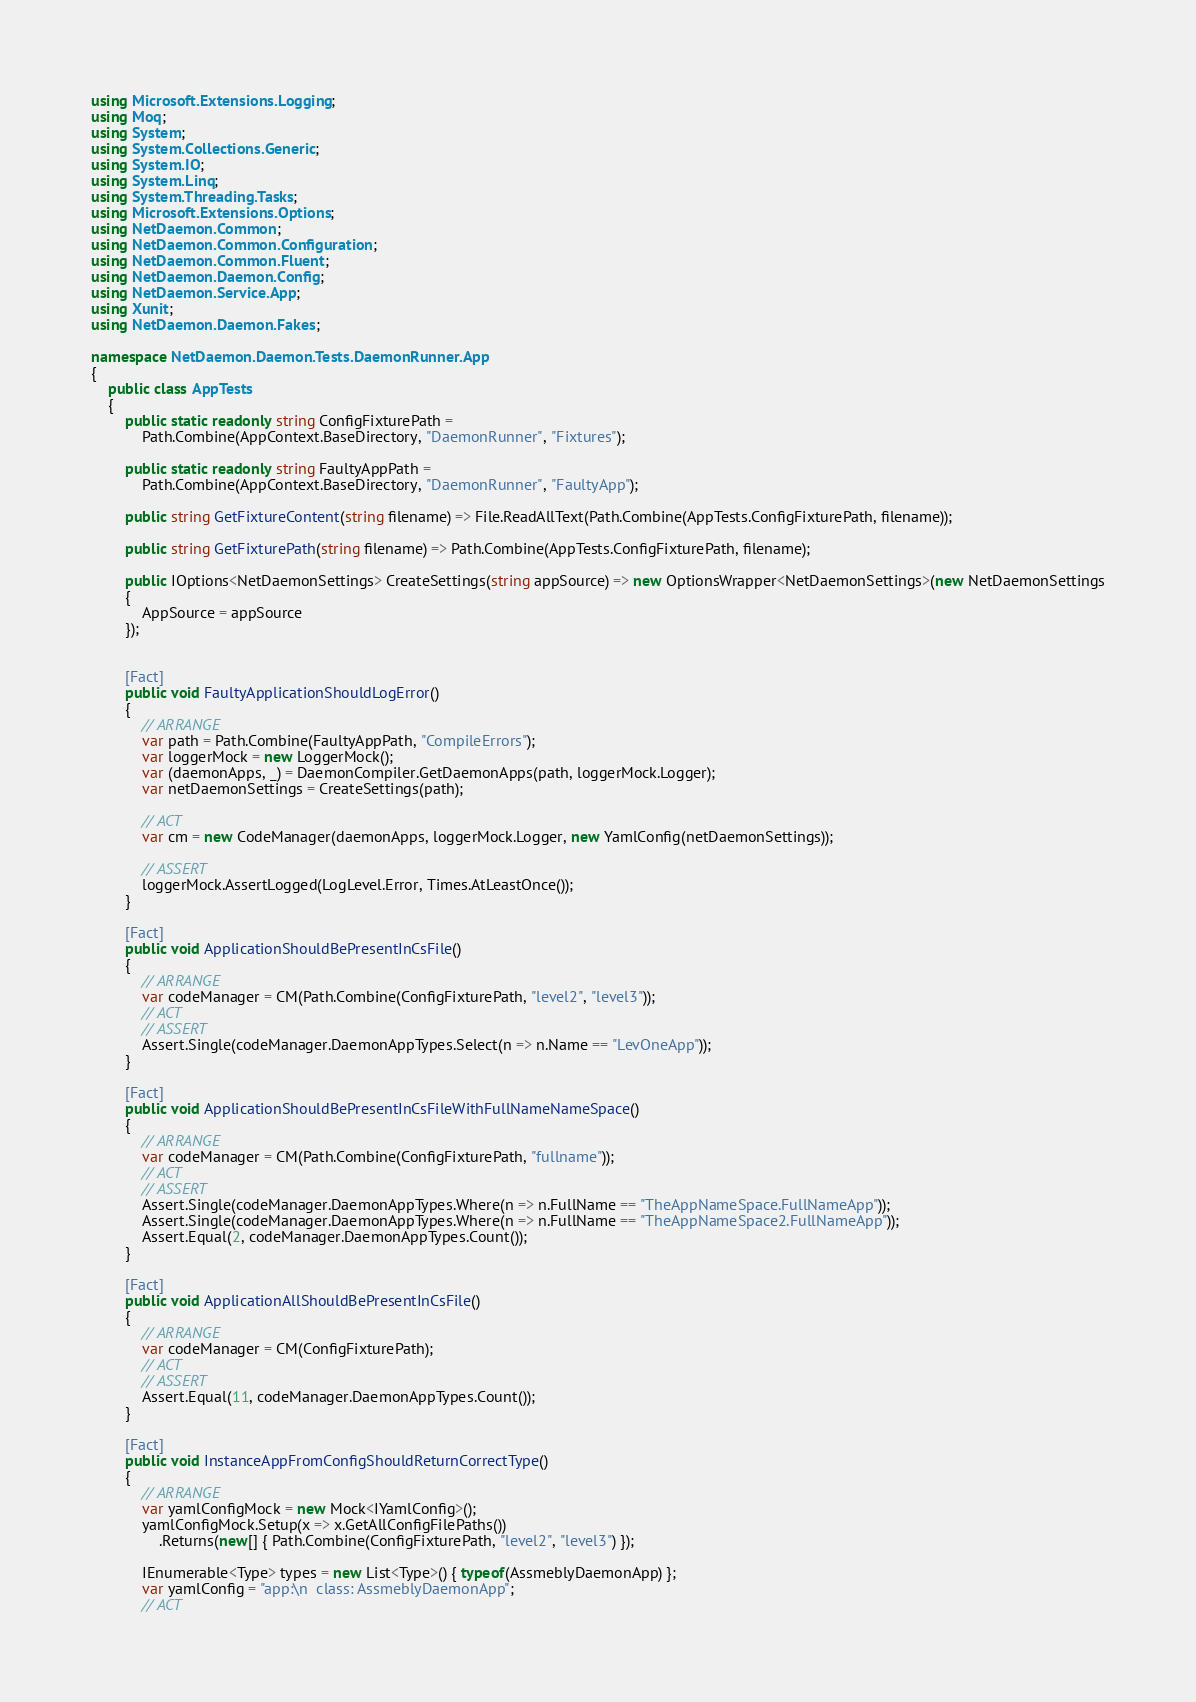<code> <loc_0><loc_0><loc_500><loc_500><_C#_>using Microsoft.Extensions.Logging;
using Moq;
using System;
using System.Collections.Generic;
using System.IO;
using System.Linq;
using System.Threading.Tasks;
using Microsoft.Extensions.Options;
using NetDaemon.Common;
using NetDaemon.Common.Configuration;
using NetDaemon.Common.Fluent;
using NetDaemon.Daemon.Config;
using NetDaemon.Service.App;
using Xunit;
using NetDaemon.Daemon.Fakes;

namespace NetDaemon.Daemon.Tests.DaemonRunner.App
{
    public class AppTests
    {
        public static readonly string ConfigFixturePath =
            Path.Combine(AppContext.BaseDirectory, "DaemonRunner", "Fixtures");

        public static readonly string FaultyAppPath =
            Path.Combine(AppContext.BaseDirectory, "DaemonRunner", "FaultyApp");

        public string GetFixtureContent(string filename) => File.ReadAllText(Path.Combine(AppTests.ConfigFixturePath, filename));

        public string GetFixturePath(string filename) => Path.Combine(AppTests.ConfigFixturePath, filename);

        public IOptions<NetDaemonSettings> CreateSettings(string appSource) => new OptionsWrapper<NetDaemonSettings>(new NetDaemonSettings
        {
            AppSource = appSource
        });


        [Fact]
        public void FaultyApplicationShouldLogError()
        {
            // ARRANGE
            var path = Path.Combine(FaultyAppPath, "CompileErrors");
            var loggerMock = new LoggerMock();
            var (daemonApps, _) = DaemonCompiler.GetDaemonApps(path, loggerMock.Logger);
            var netDaemonSettings = CreateSettings(path);

            // ACT
            var cm = new CodeManager(daemonApps, loggerMock.Logger, new YamlConfig(netDaemonSettings));

            // ASSERT
            loggerMock.AssertLogged(LogLevel.Error, Times.AtLeastOnce());
        }

        [Fact]
        public void ApplicationShouldBePresentInCsFile()
        {
            // ARRANGE
            var codeManager = CM(Path.Combine(ConfigFixturePath, "level2", "level3"));
            // ACT
            // ASSERT
            Assert.Single(codeManager.DaemonAppTypes.Select(n => n.Name == "LevOneApp"));
        }

        [Fact]
        public void ApplicationShouldBePresentInCsFileWithFullNameNameSpace()
        {
            // ARRANGE
            var codeManager = CM(Path.Combine(ConfigFixturePath, "fullname"));
            // ACT
            // ASSERT
            Assert.Single(codeManager.DaemonAppTypes.Where(n => n.FullName == "TheAppNameSpace.FullNameApp"));
            Assert.Single(codeManager.DaemonAppTypes.Where(n => n.FullName == "TheAppNameSpace2.FullNameApp"));
            Assert.Equal(2, codeManager.DaemonAppTypes.Count());
        }

        [Fact]
        public void ApplicationAllShouldBePresentInCsFile()
        {
            // ARRANGE
            var codeManager = CM(ConfigFixturePath);
            // ACT
            // ASSERT
            Assert.Equal(11, codeManager.DaemonAppTypes.Count());
        }

        [Fact]
        public void InstanceAppFromConfigShouldReturnCorrectType()
        {
            // ARRANGE
            var yamlConfigMock = new Mock<IYamlConfig>();
            yamlConfigMock.Setup(x => x.GetAllConfigFilePaths())
                .Returns(new[] { Path.Combine(ConfigFixturePath, "level2", "level3") });

            IEnumerable<Type> types = new List<Type>() { typeof(AssmeblyDaemonApp) };
            var yamlConfig = "app:\n  class: AssmeblyDaemonApp";
            // ACT</code> 